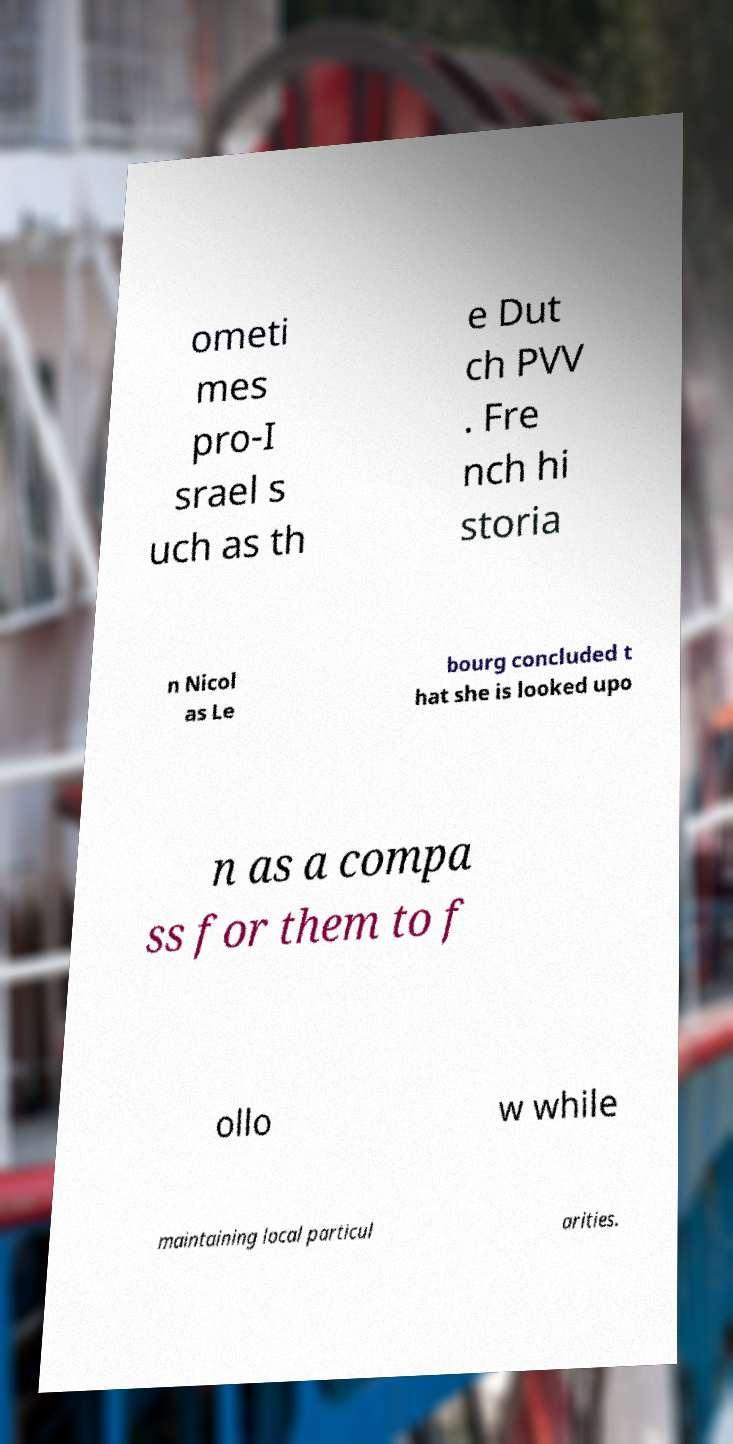Please identify and transcribe the text found in this image. ometi mes pro-I srael s uch as th e Dut ch PVV . Fre nch hi storia n Nicol as Le bourg concluded t hat she is looked upo n as a compa ss for them to f ollo w while maintaining local particul arities. 